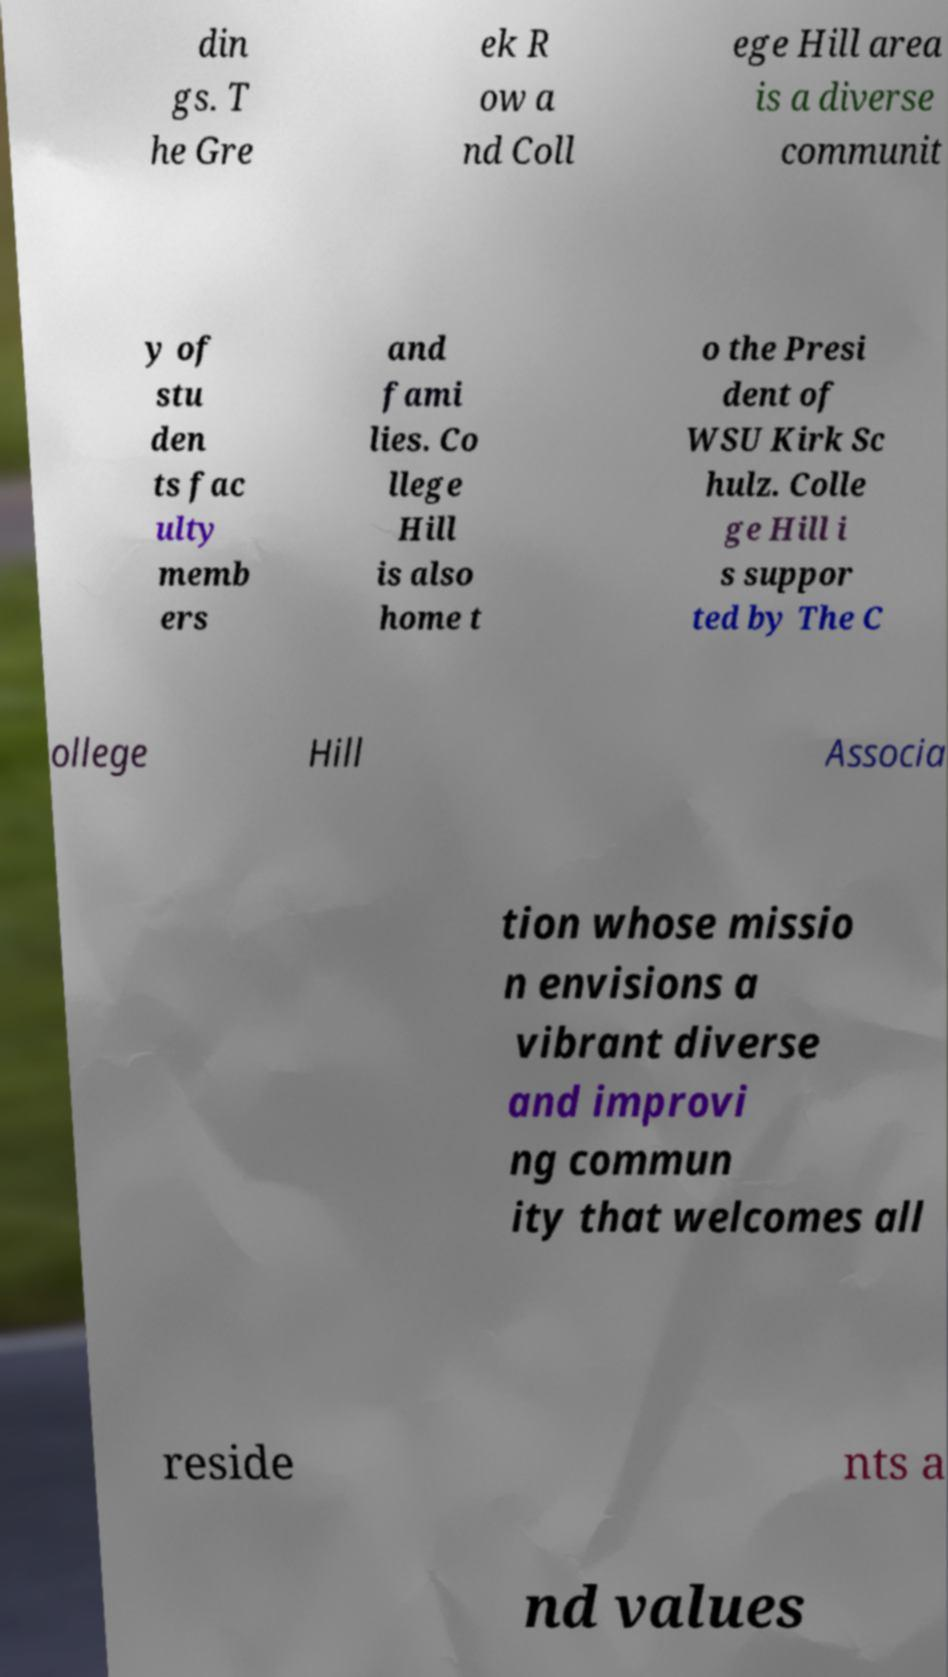For documentation purposes, I need the text within this image transcribed. Could you provide that? din gs. T he Gre ek R ow a nd Coll ege Hill area is a diverse communit y of stu den ts fac ulty memb ers and fami lies. Co llege Hill is also home t o the Presi dent of WSU Kirk Sc hulz. Colle ge Hill i s suppor ted by The C ollege Hill Associa tion whose missio n envisions a vibrant diverse and improvi ng commun ity that welcomes all reside nts a nd values 